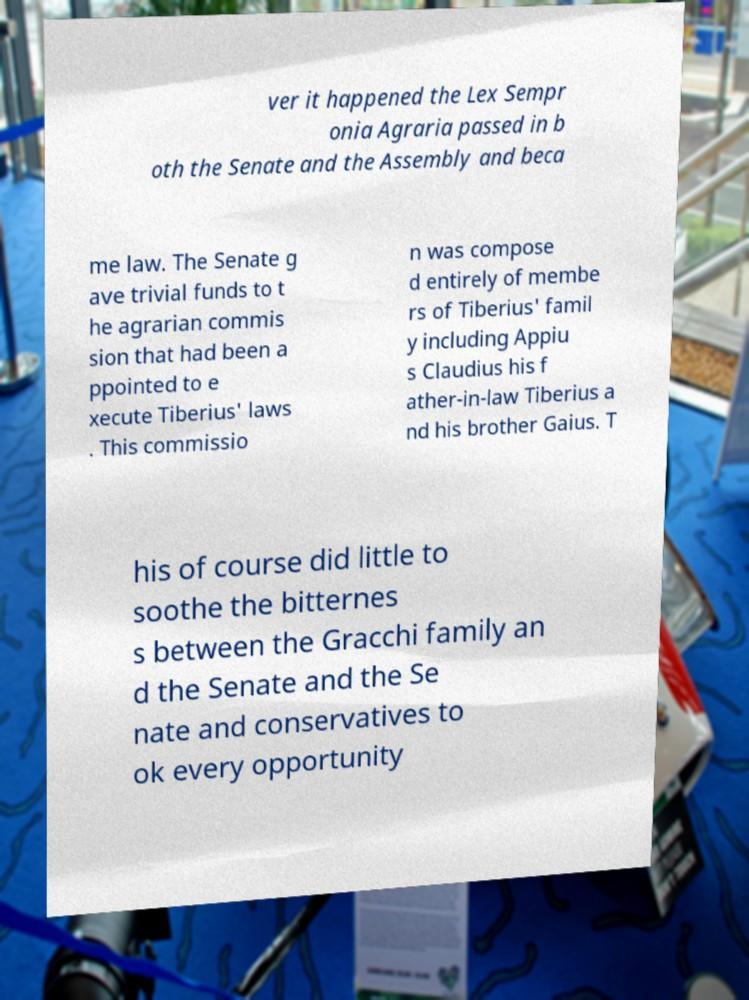Please identify and transcribe the text found in this image. ver it happened the Lex Sempr onia Agraria passed in b oth the Senate and the Assembly and beca me law. The Senate g ave trivial funds to t he agrarian commis sion that had been a ppointed to e xecute Tiberius' laws . This commissio n was compose d entirely of membe rs of Tiberius' famil y including Appiu s Claudius his f ather-in-law Tiberius a nd his brother Gaius. T his of course did little to soothe the bitternes s between the Gracchi family an d the Senate and the Se nate and conservatives to ok every opportunity 